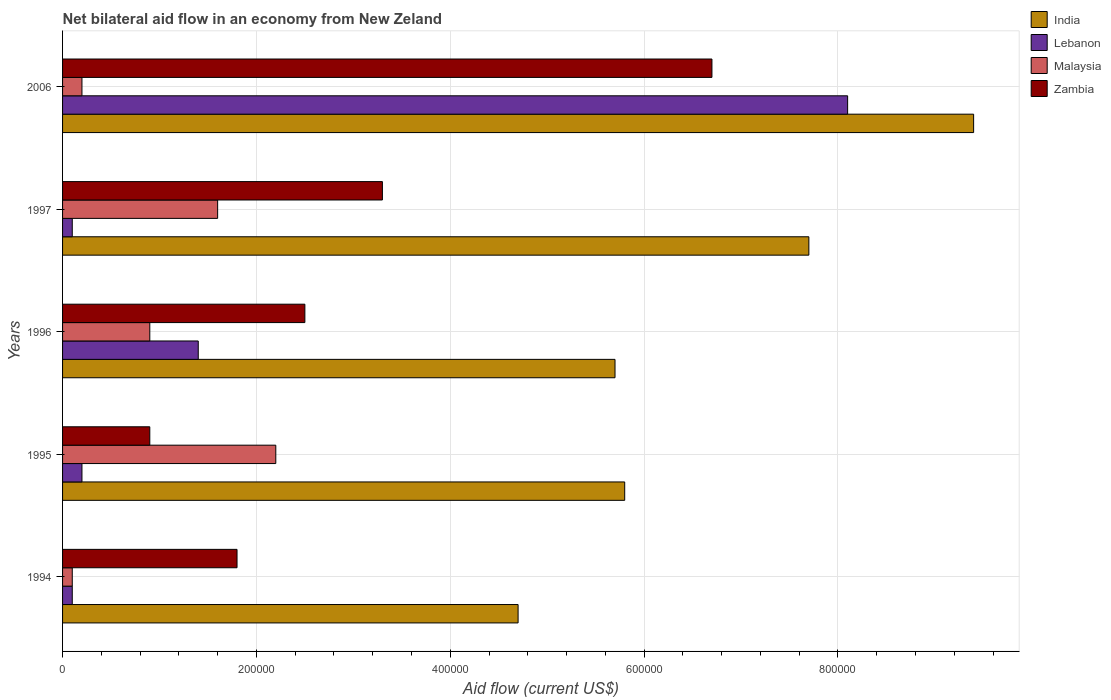How many different coloured bars are there?
Give a very brief answer. 4. Are the number of bars per tick equal to the number of legend labels?
Your answer should be very brief. Yes. Are the number of bars on each tick of the Y-axis equal?
Provide a short and direct response. Yes. How many bars are there on the 1st tick from the top?
Provide a short and direct response. 4. How many bars are there on the 5th tick from the bottom?
Provide a short and direct response. 4. What is the label of the 4th group of bars from the top?
Offer a very short reply. 1995. In how many cases, is the number of bars for a given year not equal to the number of legend labels?
Offer a terse response. 0. What is the net bilateral aid flow in Malaysia in 1996?
Provide a succinct answer. 9.00e+04. Across all years, what is the maximum net bilateral aid flow in Zambia?
Provide a short and direct response. 6.70e+05. Across all years, what is the minimum net bilateral aid flow in India?
Offer a terse response. 4.70e+05. In which year was the net bilateral aid flow in Zambia minimum?
Provide a short and direct response. 1995. What is the difference between the net bilateral aid flow in Malaysia in 1994 and the net bilateral aid flow in India in 1995?
Provide a succinct answer. -5.70e+05. In the year 1996, what is the difference between the net bilateral aid flow in Lebanon and net bilateral aid flow in India?
Ensure brevity in your answer.  -4.30e+05. What is the ratio of the net bilateral aid flow in India in 1995 to that in 1997?
Keep it short and to the point. 0.75. Is the difference between the net bilateral aid flow in Lebanon in 1994 and 1995 greater than the difference between the net bilateral aid flow in India in 1994 and 1995?
Your answer should be compact. Yes. What is the difference between the highest and the second highest net bilateral aid flow in Lebanon?
Your response must be concise. 6.70e+05. In how many years, is the net bilateral aid flow in India greater than the average net bilateral aid flow in India taken over all years?
Offer a terse response. 2. Is the sum of the net bilateral aid flow in India in 1994 and 1997 greater than the maximum net bilateral aid flow in Malaysia across all years?
Your answer should be very brief. Yes. Is it the case that in every year, the sum of the net bilateral aid flow in Zambia and net bilateral aid flow in Malaysia is greater than the sum of net bilateral aid flow in India and net bilateral aid flow in Lebanon?
Provide a succinct answer. No. What does the 1st bar from the bottom in 1994 represents?
Offer a very short reply. India. Is it the case that in every year, the sum of the net bilateral aid flow in India and net bilateral aid flow in Lebanon is greater than the net bilateral aid flow in Malaysia?
Your response must be concise. Yes. Are all the bars in the graph horizontal?
Provide a succinct answer. Yes. How many years are there in the graph?
Your answer should be compact. 5. Are the values on the major ticks of X-axis written in scientific E-notation?
Provide a short and direct response. No. Does the graph contain grids?
Give a very brief answer. Yes. Where does the legend appear in the graph?
Your response must be concise. Top right. How are the legend labels stacked?
Offer a terse response. Vertical. What is the title of the graph?
Give a very brief answer. Net bilateral aid flow in an economy from New Zeland. Does "Bulgaria" appear as one of the legend labels in the graph?
Give a very brief answer. No. What is the label or title of the X-axis?
Your answer should be compact. Aid flow (current US$). What is the label or title of the Y-axis?
Give a very brief answer. Years. What is the Aid flow (current US$) in India in 1994?
Your answer should be very brief. 4.70e+05. What is the Aid flow (current US$) in Malaysia in 1994?
Keep it short and to the point. 10000. What is the Aid flow (current US$) of India in 1995?
Your answer should be very brief. 5.80e+05. What is the Aid flow (current US$) in India in 1996?
Provide a succinct answer. 5.70e+05. What is the Aid flow (current US$) of Malaysia in 1996?
Ensure brevity in your answer.  9.00e+04. What is the Aid flow (current US$) of Zambia in 1996?
Offer a very short reply. 2.50e+05. What is the Aid flow (current US$) in India in 1997?
Your answer should be compact. 7.70e+05. What is the Aid flow (current US$) of Lebanon in 1997?
Give a very brief answer. 10000. What is the Aid flow (current US$) in Zambia in 1997?
Make the answer very short. 3.30e+05. What is the Aid flow (current US$) in India in 2006?
Keep it short and to the point. 9.40e+05. What is the Aid flow (current US$) of Lebanon in 2006?
Give a very brief answer. 8.10e+05. What is the Aid flow (current US$) of Zambia in 2006?
Your answer should be very brief. 6.70e+05. Across all years, what is the maximum Aid flow (current US$) of India?
Give a very brief answer. 9.40e+05. Across all years, what is the maximum Aid flow (current US$) of Lebanon?
Your response must be concise. 8.10e+05. Across all years, what is the maximum Aid flow (current US$) of Zambia?
Provide a short and direct response. 6.70e+05. Across all years, what is the minimum Aid flow (current US$) of Lebanon?
Offer a very short reply. 10000. Across all years, what is the minimum Aid flow (current US$) in Zambia?
Provide a succinct answer. 9.00e+04. What is the total Aid flow (current US$) of India in the graph?
Provide a short and direct response. 3.33e+06. What is the total Aid flow (current US$) of Lebanon in the graph?
Your answer should be compact. 9.90e+05. What is the total Aid flow (current US$) of Zambia in the graph?
Your response must be concise. 1.52e+06. What is the difference between the Aid flow (current US$) of Lebanon in 1994 and that in 1995?
Your answer should be compact. -10000. What is the difference between the Aid flow (current US$) in Zambia in 1994 and that in 1995?
Make the answer very short. 9.00e+04. What is the difference between the Aid flow (current US$) of India in 1994 and that in 1996?
Give a very brief answer. -1.00e+05. What is the difference between the Aid flow (current US$) of Lebanon in 1994 and that in 1996?
Give a very brief answer. -1.30e+05. What is the difference between the Aid flow (current US$) in Malaysia in 1994 and that in 1996?
Your answer should be compact. -8.00e+04. What is the difference between the Aid flow (current US$) of Zambia in 1994 and that in 1996?
Offer a very short reply. -7.00e+04. What is the difference between the Aid flow (current US$) of India in 1994 and that in 1997?
Give a very brief answer. -3.00e+05. What is the difference between the Aid flow (current US$) in Malaysia in 1994 and that in 1997?
Your answer should be compact. -1.50e+05. What is the difference between the Aid flow (current US$) in Zambia in 1994 and that in 1997?
Provide a short and direct response. -1.50e+05. What is the difference between the Aid flow (current US$) in India in 1994 and that in 2006?
Your answer should be compact. -4.70e+05. What is the difference between the Aid flow (current US$) in Lebanon in 1994 and that in 2006?
Make the answer very short. -8.00e+05. What is the difference between the Aid flow (current US$) of Malaysia in 1994 and that in 2006?
Keep it short and to the point. -10000. What is the difference between the Aid flow (current US$) in Zambia in 1994 and that in 2006?
Offer a very short reply. -4.90e+05. What is the difference between the Aid flow (current US$) in Malaysia in 1995 and that in 1997?
Offer a very short reply. 6.00e+04. What is the difference between the Aid flow (current US$) in Zambia in 1995 and that in 1997?
Your answer should be compact. -2.40e+05. What is the difference between the Aid flow (current US$) in India in 1995 and that in 2006?
Provide a short and direct response. -3.60e+05. What is the difference between the Aid flow (current US$) of Lebanon in 1995 and that in 2006?
Make the answer very short. -7.90e+05. What is the difference between the Aid flow (current US$) in Malaysia in 1995 and that in 2006?
Offer a very short reply. 2.00e+05. What is the difference between the Aid flow (current US$) in Zambia in 1995 and that in 2006?
Ensure brevity in your answer.  -5.80e+05. What is the difference between the Aid flow (current US$) in India in 1996 and that in 1997?
Ensure brevity in your answer.  -2.00e+05. What is the difference between the Aid flow (current US$) of Lebanon in 1996 and that in 1997?
Offer a very short reply. 1.30e+05. What is the difference between the Aid flow (current US$) of Zambia in 1996 and that in 1997?
Ensure brevity in your answer.  -8.00e+04. What is the difference between the Aid flow (current US$) of India in 1996 and that in 2006?
Your answer should be compact. -3.70e+05. What is the difference between the Aid flow (current US$) of Lebanon in 1996 and that in 2006?
Provide a short and direct response. -6.70e+05. What is the difference between the Aid flow (current US$) in Zambia in 1996 and that in 2006?
Ensure brevity in your answer.  -4.20e+05. What is the difference between the Aid flow (current US$) of India in 1997 and that in 2006?
Provide a succinct answer. -1.70e+05. What is the difference between the Aid flow (current US$) in Lebanon in 1997 and that in 2006?
Your answer should be compact. -8.00e+05. What is the difference between the Aid flow (current US$) of Malaysia in 1997 and that in 2006?
Your response must be concise. 1.40e+05. What is the difference between the Aid flow (current US$) of India in 1994 and the Aid flow (current US$) of Malaysia in 1995?
Offer a very short reply. 2.50e+05. What is the difference between the Aid flow (current US$) in India in 1994 and the Aid flow (current US$) in Zambia in 1995?
Your answer should be very brief. 3.80e+05. What is the difference between the Aid flow (current US$) in Lebanon in 1994 and the Aid flow (current US$) in Malaysia in 1995?
Offer a terse response. -2.10e+05. What is the difference between the Aid flow (current US$) in Malaysia in 1994 and the Aid flow (current US$) in Zambia in 1995?
Your response must be concise. -8.00e+04. What is the difference between the Aid flow (current US$) of India in 1994 and the Aid flow (current US$) of Zambia in 1996?
Your answer should be very brief. 2.20e+05. What is the difference between the Aid flow (current US$) in Lebanon in 1994 and the Aid flow (current US$) in Malaysia in 1996?
Keep it short and to the point. -8.00e+04. What is the difference between the Aid flow (current US$) in Malaysia in 1994 and the Aid flow (current US$) in Zambia in 1996?
Keep it short and to the point. -2.40e+05. What is the difference between the Aid flow (current US$) in Lebanon in 1994 and the Aid flow (current US$) in Malaysia in 1997?
Provide a short and direct response. -1.50e+05. What is the difference between the Aid flow (current US$) of Lebanon in 1994 and the Aid flow (current US$) of Zambia in 1997?
Provide a short and direct response. -3.20e+05. What is the difference between the Aid flow (current US$) in Malaysia in 1994 and the Aid flow (current US$) in Zambia in 1997?
Provide a short and direct response. -3.20e+05. What is the difference between the Aid flow (current US$) in India in 1994 and the Aid flow (current US$) in Malaysia in 2006?
Provide a short and direct response. 4.50e+05. What is the difference between the Aid flow (current US$) in India in 1994 and the Aid flow (current US$) in Zambia in 2006?
Provide a short and direct response. -2.00e+05. What is the difference between the Aid flow (current US$) in Lebanon in 1994 and the Aid flow (current US$) in Zambia in 2006?
Give a very brief answer. -6.60e+05. What is the difference between the Aid flow (current US$) of Malaysia in 1994 and the Aid flow (current US$) of Zambia in 2006?
Give a very brief answer. -6.60e+05. What is the difference between the Aid flow (current US$) in India in 1995 and the Aid flow (current US$) in Lebanon in 1996?
Your response must be concise. 4.40e+05. What is the difference between the Aid flow (current US$) of India in 1995 and the Aid flow (current US$) of Malaysia in 1996?
Give a very brief answer. 4.90e+05. What is the difference between the Aid flow (current US$) of India in 1995 and the Aid flow (current US$) of Zambia in 1996?
Your answer should be compact. 3.30e+05. What is the difference between the Aid flow (current US$) in Lebanon in 1995 and the Aid flow (current US$) in Malaysia in 1996?
Offer a terse response. -7.00e+04. What is the difference between the Aid flow (current US$) in Lebanon in 1995 and the Aid flow (current US$) in Zambia in 1996?
Make the answer very short. -2.30e+05. What is the difference between the Aid flow (current US$) of Malaysia in 1995 and the Aid flow (current US$) of Zambia in 1996?
Your response must be concise. -3.00e+04. What is the difference between the Aid flow (current US$) of India in 1995 and the Aid flow (current US$) of Lebanon in 1997?
Keep it short and to the point. 5.70e+05. What is the difference between the Aid flow (current US$) of India in 1995 and the Aid flow (current US$) of Malaysia in 1997?
Your answer should be compact. 4.20e+05. What is the difference between the Aid flow (current US$) of India in 1995 and the Aid flow (current US$) of Zambia in 1997?
Keep it short and to the point. 2.50e+05. What is the difference between the Aid flow (current US$) in Lebanon in 1995 and the Aid flow (current US$) in Malaysia in 1997?
Your answer should be very brief. -1.40e+05. What is the difference between the Aid flow (current US$) in Lebanon in 1995 and the Aid flow (current US$) in Zambia in 1997?
Your answer should be compact. -3.10e+05. What is the difference between the Aid flow (current US$) of Malaysia in 1995 and the Aid flow (current US$) of Zambia in 1997?
Make the answer very short. -1.10e+05. What is the difference between the Aid flow (current US$) of India in 1995 and the Aid flow (current US$) of Lebanon in 2006?
Provide a short and direct response. -2.30e+05. What is the difference between the Aid flow (current US$) in India in 1995 and the Aid flow (current US$) in Malaysia in 2006?
Provide a short and direct response. 5.60e+05. What is the difference between the Aid flow (current US$) in Lebanon in 1995 and the Aid flow (current US$) in Zambia in 2006?
Your answer should be compact. -6.50e+05. What is the difference between the Aid flow (current US$) of Malaysia in 1995 and the Aid flow (current US$) of Zambia in 2006?
Your answer should be very brief. -4.50e+05. What is the difference between the Aid flow (current US$) in India in 1996 and the Aid flow (current US$) in Lebanon in 1997?
Your answer should be compact. 5.60e+05. What is the difference between the Aid flow (current US$) of India in 1996 and the Aid flow (current US$) of Malaysia in 1997?
Offer a very short reply. 4.10e+05. What is the difference between the Aid flow (current US$) in India in 1996 and the Aid flow (current US$) in Zambia in 1997?
Your response must be concise. 2.40e+05. What is the difference between the Aid flow (current US$) of Lebanon in 1996 and the Aid flow (current US$) of Malaysia in 1997?
Make the answer very short. -2.00e+04. What is the difference between the Aid flow (current US$) of Lebanon in 1996 and the Aid flow (current US$) of Zambia in 2006?
Ensure brevity in your answer.  -5.30e+05. What is the difference between the Aid flow (current US$) in Malaysia in 1996 and the Aid flow (current US$) in Zambia in 2006?
Your response must be concise. -5.80e+05. What is the difference between the Aid flow (current US$) of India in 1997 and the Aid flow (current US$) of Malaysia in 2006?
Your response must be concise. 7.50e+05. What is the difference between the Aid flow (current US$) of India in 1997 and the Aid flow (current US$) of Zambia in 2006?
Your answer should be very brief. 1.00e+05. What is the difference between the Aid flow (current US$) of Lebanon in 1997 and the Aid flow (current US$) of Malaysia in 2006?
Your answer should be very brief. -10000. What is the difference between the Aid flow (current US$) in Lebanon in 1997 and the Aid flow (current US$) in Zambia in 2006?
Ensure brevity in your answer.  -6.60e+05. What is the difference between the Aid flow (current US$) in Malaysia in 1997 and the Aid flow (current US$) in Zambia in 2006?
Your answer should be compact. -5.10e+05. What is the average Aid flow (current US$) in India per year?
Your answer should be very brief. 6.66e+05. What is the average Aid flow (current US$) in Lebanon per year?
Offer a terse response. 1.98e+05. What is the average Aid flow (current US$) in Malaysia per year?
Offer a very short reply. 1.00e+05. What is the average Aid flow (current US$) of Zambia per year?
Offer a terse response. 3.04e+05. In the year 1994, what is the difference between the Aid flow (current US$) in India and Aid flow (current US$) in Malaysia?
Offer a very short reply. 4.60e+05. In the year 1994, what is the difference between the Aid flow (current US$) in India and Aid flow (current US$) in Zambia?
Provide a short and direct response. 2.90e+05. In the year 1994, what is the difference between the Aid flow (current US$) of Lebanon and Aid flow (current US$) of Malaysia?
Your answer should be compact. 0. In the year 1994, what is the difference between the Aid flow (current US$) of Lebanon and Aid flow (current US$) of Zambia?
Keep it short and to the point. -1.70e+05. In the year 1994, what is the difference between the Aid flow (current US$) of Malaysia and Aid flow (current US$) of Zambia?
Ensure brevity in your answer.  -1.70e+05. In the year 1995, what is the difference between the Aid flow (current US$) of India and Aid flow (current US$) of Lebanon?
Offer a very short reply. 5.60e+05. In the year 1995, what is the difference between the Aid flow (current US$) of India and Aid flow (current US$) of Zambia?
Keep it short and to the point. 4.90e+05. In the year 1995, what is the difference between the Aid flow (current US$) of Malaysia and Aid flow (current US$) of Zambia?
Provide a succinct answer. 1.30e+05. In the year 1996, what is the difference between the Aid flow (current US$) in India and Aid flow (current US$) in Lebanon?
Provide a succinct answer. 4.30e+05. In the year 1996, what is the difference between the Aid flow (current US$) of India and Aid flow (current US$) of Zambia?
Your response must be concise. 3.20e+05. In the year 1997, what is the difference between the Aid flow (current US$) of India and Aid flow (current US$) of Lebanon?
Make the answer very short. 7.60e+05. In the year 1997, what is the difference between the Aid flow (current US$) in Lebanon and Aid flow (current US$) in Zambia?
Your response must be concise. -3.20e+05. In the year 2006, what is the difference between the Aid flow (current US$) in India and Aid flow (current US$) in Lebanon?
Offer a very short reply. 1.30e+05. In the year 2006, what is the difference between the Aid flow (current US$) in India and Aid flow (current US$) in Malaysia?
Offer a terse response. 9.20e+05. In the year 2006, what is the difference between the Aid flow (current US$) of India and Aid flow (current US$) of Zambia?
Your response must be concise. 2.70e+05. In the year 2006, what is the difference between the Aid flow (current US$) in Lebanon and Aid flow (current US$) in Malaysia?
Your response must be concise. 7.90e+05. In the year 2006, what is the difference between the Aid flow (current US$) of Lebanon and Aid flow (current US$) of Zambia?
Offer a very short reply. 1.40e+05. In the year 2006, what is the difference between the Aid flow (current US$) of Malaysia and Aid flow (current US$) of Zambia?
Give a very brief answer. -6.50e+05. What is the ratio of the Aid flow (current US$) of India in 1994 to that in 1995?
Keep it short and to the point. 0.81. What is the ratio of the Aid flow (current US$) in Malaysia in 1994 to that in 1995?
Ensure brevity in your answer.  0.05. What is the ratio of the Aid flow (current US$) in India in 1994 to that in 1996?
Your answer should be very brief. 0.82. What is the ratio of the Aid flow (current US$) of Lebanon in 1994 to that in 1996?
Make the answer very short. 0.07. What is the ratio of the Aid flow (current US$) in Zambia in 1994 to that in 1996?
Provide a succinct answer. 0.72. What is the ratio of the Aid flow (current US$) in India in 1994 to that in 1997?
Provide a short and direct response. 0.61. What is the ratio of the Aid flow (current US$) in Lebanon in 1994 to that in 1997?
Offer a very short reply. 1. What is the ratio of the Aid flow (current US$) of Malaysia in 1994 to that in 1997?
Offer a terse response. 0.06. What is the ratio of the Aid flow (current US$) in Zambia in 1994 to that in 1997?
Offer a very short reply. 0.55. What is the ratio of the Aid flow (current US$) in India in 1994 to that in 2006?
Provide a succinct answer. 0.5. What is the ratio of the Aid flow (current US$) in Lebanon in 1994 to that in 2006?
Offer a very short reply. 0.01. What is the ratio of the Aid flow (current US$) in Zambia in 1994 to that in 2006?
Offer a terse response. 0.27. What is the ratio of the Aid flow (current US$) in India in 1995 to that in 1996?
Make the answer very short. 1.02. What is the ratio of the Aid flow (current US$) of Lebanon in 1995 to that in 1996?
Your answer should be very brief. 0.14. What is the ratio of the Aid flow (current US$) of Malaysia in 1995 to that in 1996?
Offer a terse response. 2.44. What is the ratio of the Aid flow (current US$) of Zambia in 1995 to that in 1996?
Your answer should be compact. 0.36. What is the ratio of the Aid flow (current US$) of India in 1995 to that in 1997?
Ensure brevity in your answer.  0.75. What is the ratio of the Aid flow (current US$) in Lebanon in 1995 to that in 1997?
Your response must be concise. 2. What is the ratio of the Aid flow (current US$) of Malaysia in 1995 to that in 1997?
Give a very brief answer. 1.38. What is the ratio of the Aid flow (current US$) in Zambia in 1995 to that in 1997?
Your response must be concise. 0.27. What is the ratio of the Aid flow (current US$) in India in 1995 to that in 2006?
Keep it short and to the point. 0.62. What is the ratio of the Aid flow (current US$) of Lebanon in 1995 to that in 2006?
Your response must be concise. 0.02. What is the ratio of the Aid flow (current US$) in Malaysia in 1995 to that in 2006?
Ensure brevity in your answer.  11. What is the ratio of the Aid flow (current US$) of Zambia in 1995 to that in 2006?
Keep it short and to the point. 0.13. What is the ratio of the Aid flow (current US$) of India in 1996 to that in 1997?
Give a very brief answer. 0.74. What is the ratio of the Aid flow (current US$) in Malaysia in 1996 to that in 1997?
Give a very brief answer. 0.56. What is the ratio of the Aid flow (current US$) in Zambia in 1996 to that in 1997?
Provide a short and direct response. 0.76. What is the ratio of the Aid flow (current US$) in India in 1996 to that in 2006?
Offer a very short reply. 0.61. What is the ratio of the Aid flow (current US$) of Lebanon in 1996 to that in 2006?
Provide a succinct answer. 0.17. What is the ratio of the Aid flow (current US$) of Malaysia in 1996 to that in 2006?
Give a very brief answer. 4.5. What is the ratio of the Aid flow (current US$) in Zambia in 1996 to that in 2006?
Ensure brevity in your answer.  0.37. What is the ratio of the Aid flow (current US$) in India in 1997 to that in 2006?
Your answer should be compact. 0.82. What is the ratio of the Aid flow (current US$) in Lebanon in 1997 to that in 2006?
Provide a short and direct response. 0.01. What is the ratio of the Aid flow (current US$) in Malaysia in 1997 to that in 2006?
Provide a short and direct response. 8. What is the ratio of the Aid flow (current US$) of Zambia in 1997 to that in 2006?
Your answer should be compact. 0.49. What is the difference between the highest and the second highest Aid flow (current US$) of India?
Keep it short and to the point. 1.70e+05. What is the difference between the highest and the second highest Aid flow (current US$) of Lebanon?
Offer a very short reply. 6.70e+05. What is the difference between the highest and the lowest Aid flow (current US$) of Lebanon?
Give a very brief answer. 8.00e+05. What is the difference between the highest and the lowest Aid flow (current US$) of Zambia?
Keep it short and to the point. 5.80e+05. 